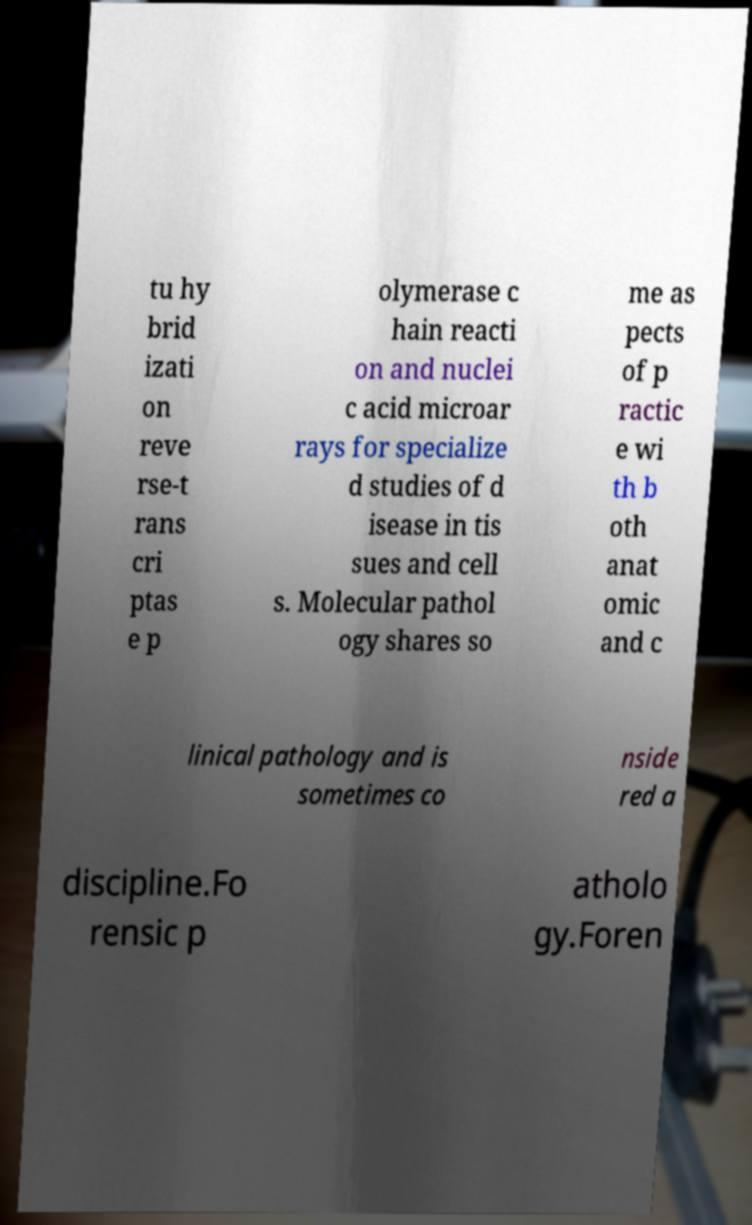What messages or text are displayed in this image? I need them in a readable, typed format. tu hy brid izati on reve rse-t rans cri ptas e p olymerase c hain reacti on and nuclei c acid microar rays for specialize d studies of d isease in tis sues and cell s. Molecular pathol ogy shares so me as pects of p ractic e wi th b oth anat omic and c linical pathology and is sometimes co nside red a discipline.Fo rensic p atholo gy.Foren 